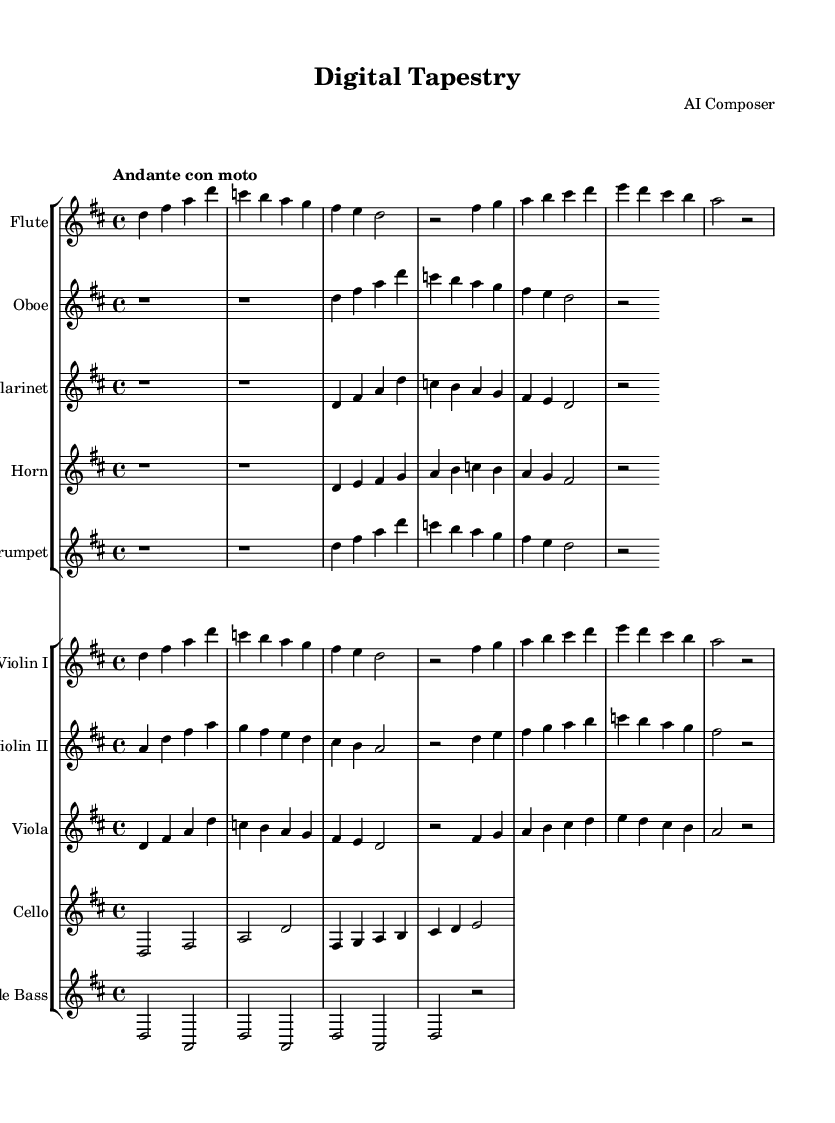What is the key signature of this music? The key signature is indicated right after the clef at the beginning of the staff, showing two sharps. This corresponds to D major.
Answer: D major What is the time signature of this music? The time signature is located at the beginning of the score after the key signature. It is written as 4/4, which means there are four beats in each measure.
Answer: 4/4 What is the tempo marking of the piece? The tempo marking is indicated in Italian as "Andante con moto." It signifies a moderately slow tempo with a sense of motion.
Answer: Andante con moto How many measures are in the first flute part? By counting the number of vertical lines in the flute's section, we find there are six measures presented.
Answer: 6 Which instrument has a rest for the first two measures? Observing the score, we see that the oboe part has two whole measures of rest at the beginning indicated by "r1 r1."
Answer: Oboe What is the highest note played by the violins? Looking at the violin I part, the highest note is B, which occurs in the second measure of the first line.
Answer: B In what way does the cello part contribute to the overall harmony in this piece? The cello part supports the harmony by playing the root notes of the chords that underpin the melodic lines and adds depth to the texture. In its first measure, the cello plays D, which is foundational for the D major key.
Answer: Root notes 